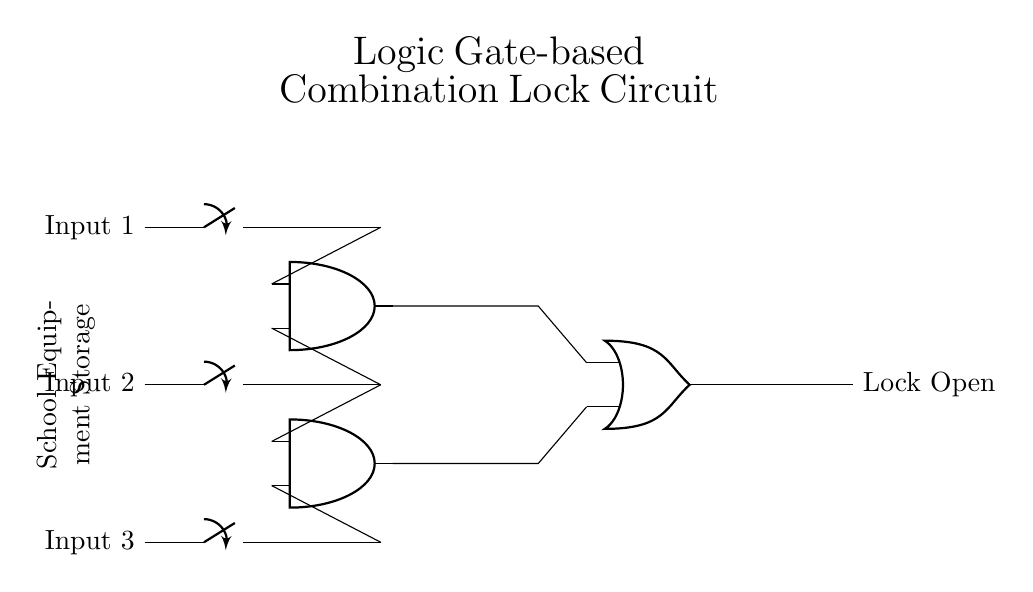What are the main components in this circuit? The main components are three input switches, two AND gates, and one OR gate. These elements work together to control the output of the circuit.
Answer: Input switches, AND gates, OR gate How many AND gates are in the circuit? There are two AND gates in this circuit, indicated by the two symbols labeled as AND in the diagram.
Answer: Two What is the output of this circuit? The output, labeled "Lock Open," indicates the state of the lock when the correct conditions are met, primarily driven by the inputs through the gates.
Answer: Lock Open What do the input switches represent? The input switches signify the user inputs needed for the lock operation. Each must be closed (or engaged) to contribute to unlocking the storage.
Answer: User inputs What is the function of the OR gate in this circuit? The OR gate combines the outputs of the two AND gates, providing a single output signal that controls whether the lock opens, depending on at least one AND condition being satisfied.
Answer: Combine outputs How many input conditions are required for the lock to open? At least one of the AND gates needs to have both of its inputs activated (closed) to provide a high signal to the OR gate for the output to be true (lock open).
Answer: Two (for each AND gate) Why are there two AND gates in the circuit? The presence of two AND gates allows for multiple combinations of inputs to be accepted; this increases the flexibility for different locking combinations depending on how the switches are configured.
Answer: To allow for multiple combinations 